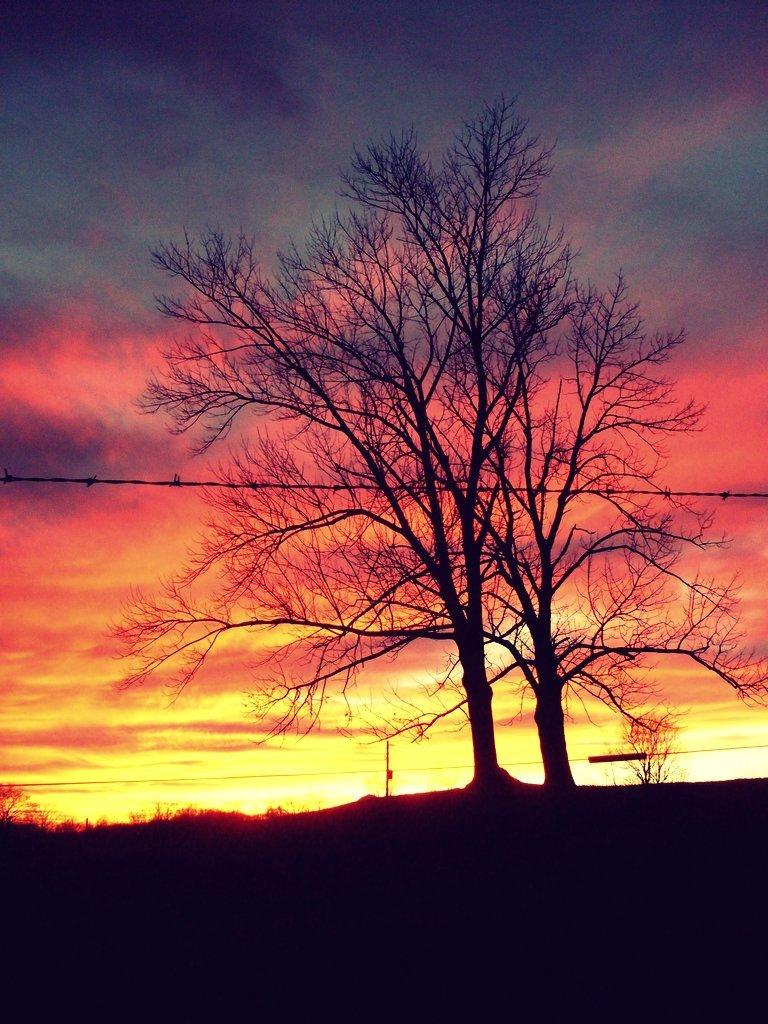What type of natural elements can be seen in the image? There are trees in the image. What man-made object is visible in the image? There is a cable visible in the image. Can you describe the other objects in the image? There are other objects in the image, but their specific details are not mentioned in the provided facts. What is visible in the background of the image? The sky is visible in the background of the image. What is the color of the surface at the bottom of the image? The surface at the bottom of the image is black. What type of pain is the person experiencing in the image? There is no person present in the image, and therefore no indication of any pain being experienced. What type of wool is used to make the sweater in the image? There is no sweater or wool present in the image. 